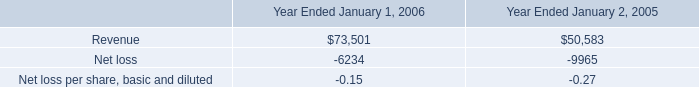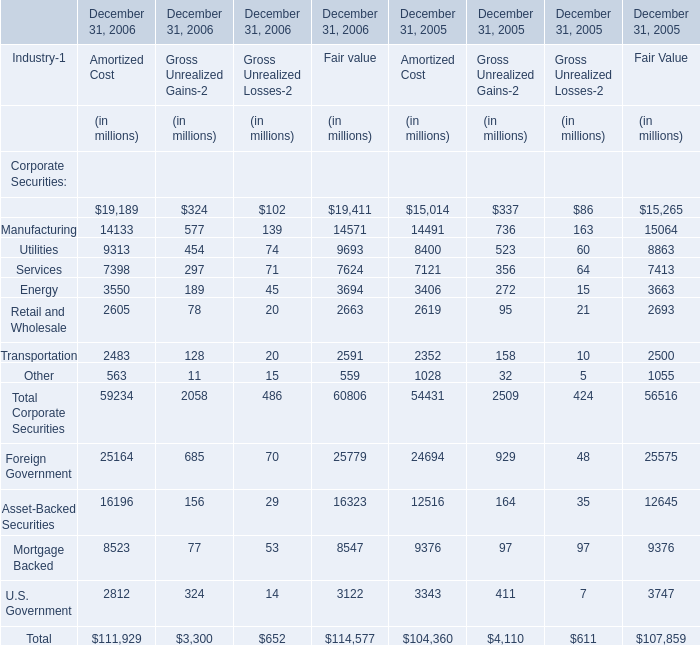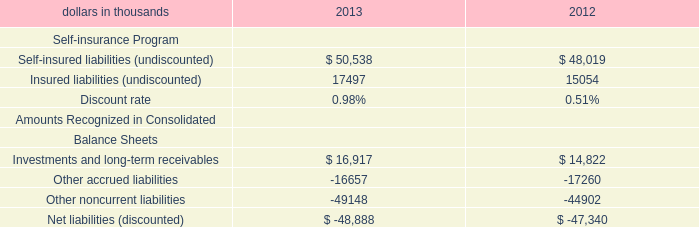what was the percentage change in revenues between 2005 and 2006? 
Computations: ((73501 - 50583) / 50583)
Answer: 0.45308. 